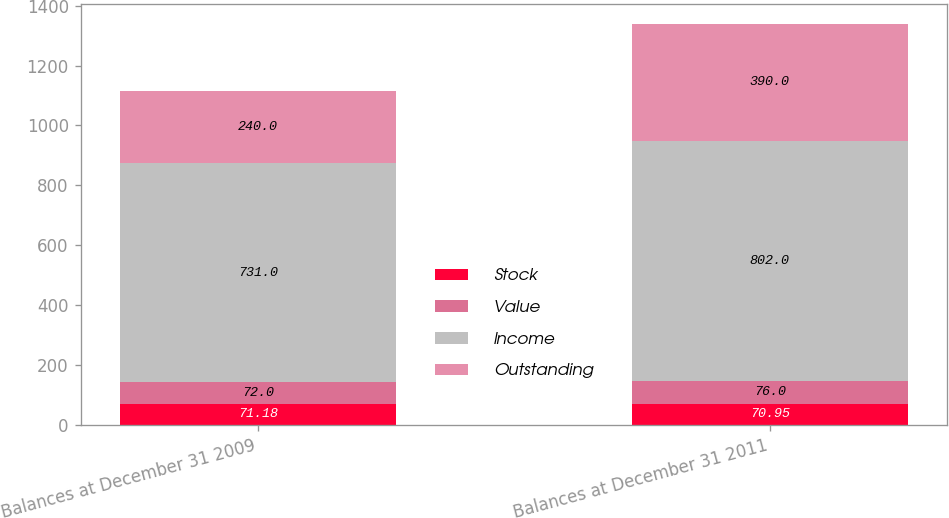<chart> <loc_0><loc_0><loc_500><loc_500><stacked_bar_chart><ecel><fcel>Balances at December 31 2009<fcel>Balances at December 31 2011<nl><fcel>Stock<fcel>71.18<fcel>70.95<nl><fcel>Value<fcel>72<fcel>76<nl><fcel>Income<fcel>731<fcel>802<nl><fcel>Outstanding<fcel>240<fcel>390<nl></chart> 